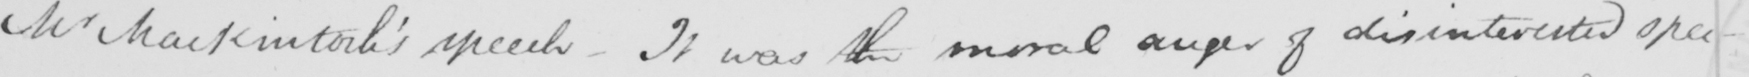Please provide the text content of this handwritten line. Mr MacKintosh ' s speech  _  It was the moral anger of disinterested spec- 